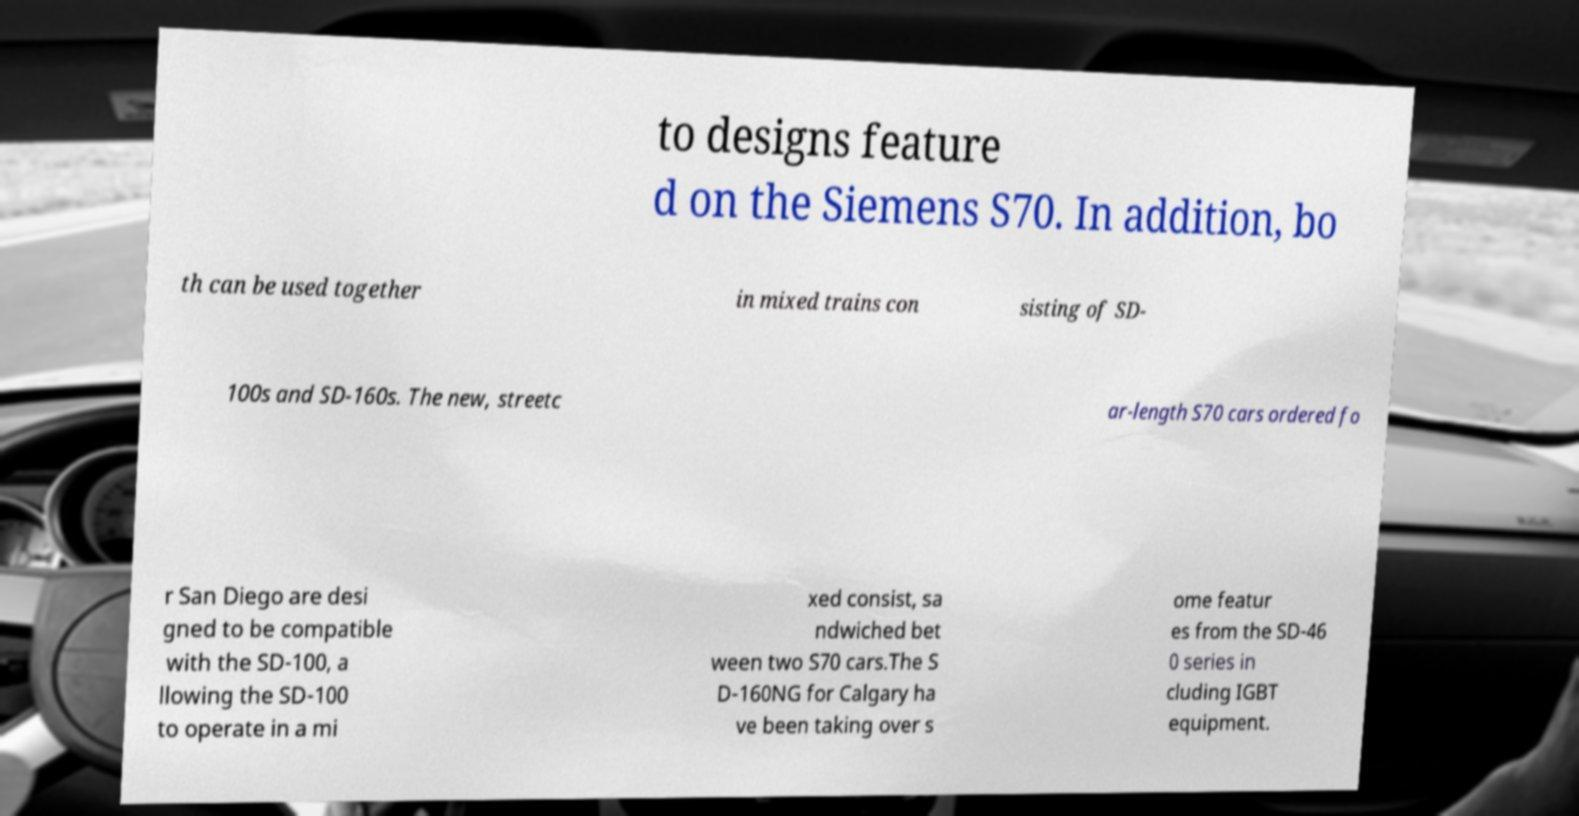What messages or text are displayed in this image? I need them in a readable, typed format. to designs feature d on the Siemens S70. In addition, bo th can be used together in mixed trains con sisting of SD- 100s and SD-160s. The new, streetc ar-length S70 cars ordered fo r San Diego are desi gned to be compatible with the SD-100, a llowing the SD-100 to operate in a mi xed consist, sa ndwiched bet ween two S70 cars.The S D-160NG for Calgary ha ve been taking over s ome featur es from the SD-46 0 series in cluding IGBT equipment. 